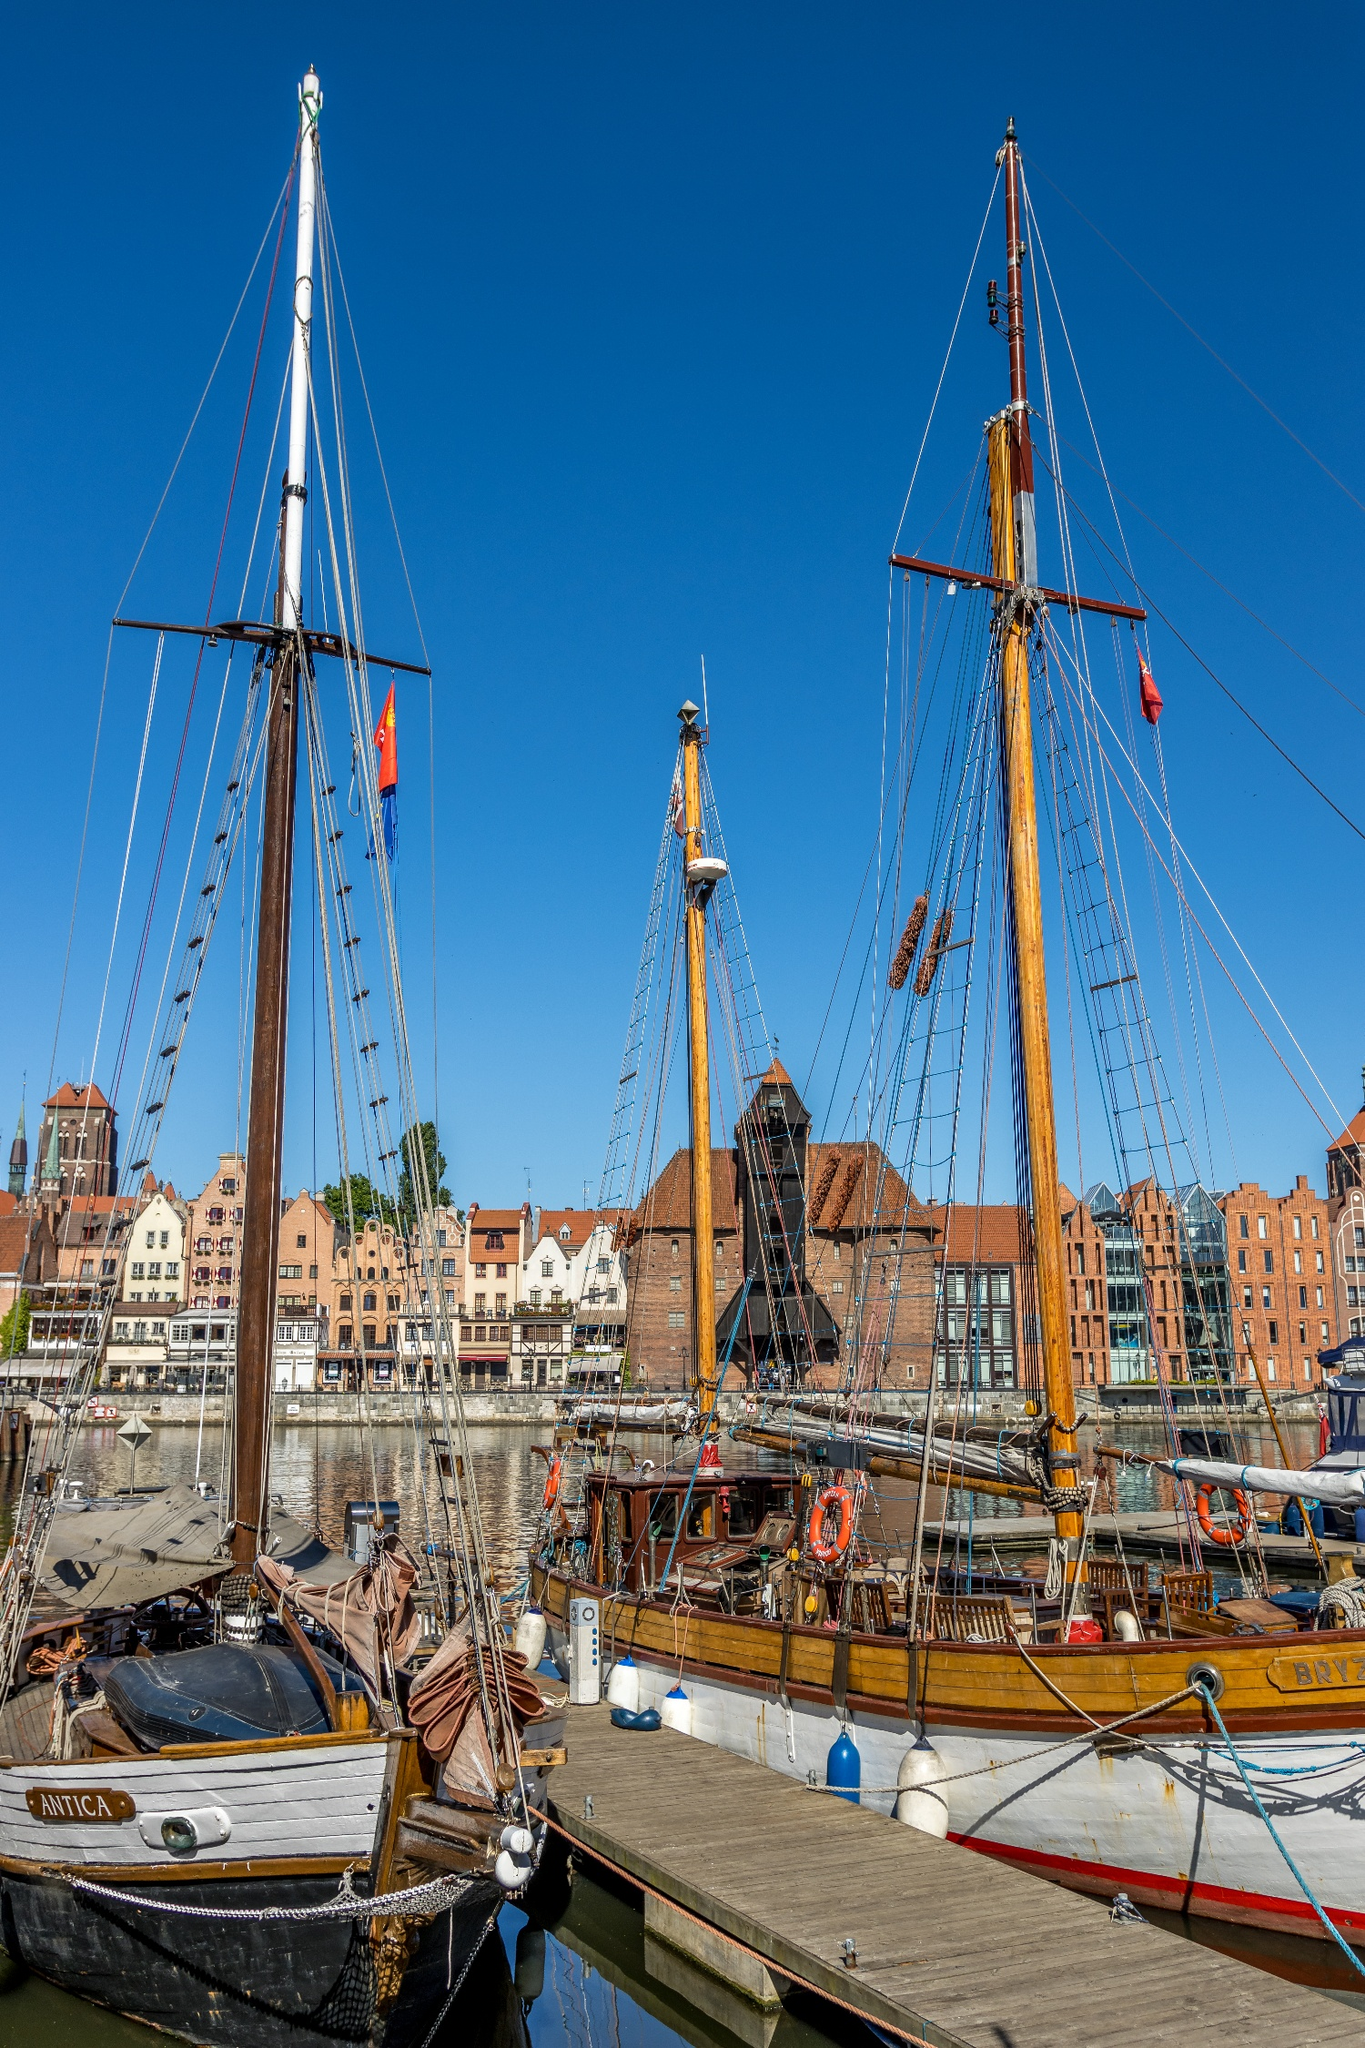Can you discuss any historical events associated with Gdansk harbor? Gdansk harbor has a rich history as a major port of trade in Northern Europe, significantly during the time of the Hanseatic League in the Middle Ages. It was a crucial point for commerce and exchange between various European countries, dealing in goods such as grain and amber. More recently, Gdansk was a focal point during World War II and played a significant role in the 20th-century Polish Solidarity movement, which was pivotal in the downfall of communism in Eastern Europe. The harbor therefore not only serves as a cultural and historical landmark but also a symbol of resistance and resilience in the face of political and social upheaval. 